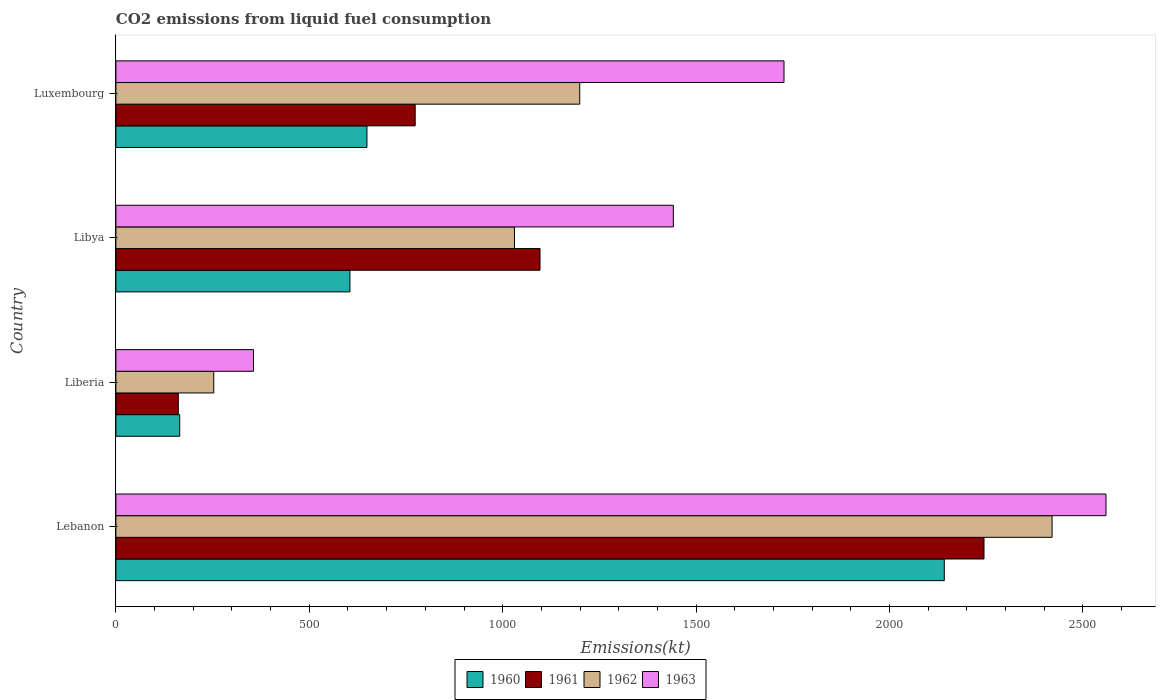How many bars are there on the 3rd tick from the top?
Offer a terse response. 4. How many bars are there on the 2nd tick from the bottom?
Make the answer very short. 4. What is the label of the 4th group of bars from the top?
Offer a terse response. Lebanon. What is the amount of CO2 emitted in 1963 in Libya?
Offer a very short reply. 1441.13. Across all countries, what is the maximum amount of CO2 emitted in 1961?
Give a very brief answer. 2244.2. Across all countries, what is the minimum amount of CO2 emitted in 1960?
Your answer should be very brief. 165.01. In which country was the amount of CO2 emitted in 1960 maximum?
Offer a very short reply. Lebanon. In which country was the amount of CO2 emitted in 1960 minimum?
Keep it short and to the point. Liberia. What is the total amount of CO2 emitted in 1963 in the graph?
Ensure brevity in your answer.  6083.55. What is the difference between the amount of CO2 emitted in 1962 in Lebanon and that in Liberia?
Make the answer very short. 2167.2. What is the difference between the amount of CO2 emitted in 1960 in Liberia and the amount of CO2 emitted in 1961 in Luxembourg?
Give a very brief answer. -608.72. What is the average amount of CO2 emitted in 1961 per country?
Provide a short and direct response. 1068.93. What is the difference between the amount of CO2 emitted in 1963 and amount of CO2 emitted in 1962 in Liberia?
Your answer should be compact. 102.68. What is the ratio of the amount of CO2 emitted in 1961 in Libya to that in Luxembourg?
Ensure brevity in your answer.  1.42. Is the amount of CO2 emitted in 1960 in Libya less than that in Luxembourg?
Offer a terse response. Yes. What is the difference between the highest and the second highest amount of CO2 emitted in 1960?
Keep it short and to the point. 1492.47. What is the difference between the highest and the lowest amount of CO2 emitted in 1960?
Offer a very short reply. 1976.51. In how many countries, is the amount of CO2 emitted in 1962 greater than the average amount of CO2 emitted in 1962 taken over all countries?
Keep it short and to the point. 1. Is it the case that in every country, the sum of the amount of CO2 emitted in 1961 and amount of CO2 emitted in 1963 is greater than the sum of amount of CO2 emitted in 1960 and amount of CO2 emitted in 1962?
Keep it short and to the point. No. How many bars are there?
Give a very brief answer. 16. Are all the bars in the graph horizontal?
Your answer should be very brief. Yes. Are the values on the major ticks of X-axis written in scientific E-notation?
Provide a succinct answer. No. Does the graph contain any zero values?
Keep it short and to the point. No. Does the graph contain grids?
Offer a very short reply. No. Where does the legend appear in the graph?
Keep it short and to the point. Bottom center. How many legend labels are there?
Make the answer very short. 4. What is the title of the graph?
Make the answer very short. CO2 emissions from liquid fuel consumption. What is the label or title of the X-axis?
Ensure brevity in your answer.  Emissions(kt). What is the label or title of the Y-axis?
Keep it short and to the point. Country. What is the Emissions(kt) of 1960 in Lebanon?
Offer a terse response. 2141.53. What is the Emissions(kt) of 1961 in Lebanon?
Give a very brief answer. 2244.2. What is the Emissions(kt) of 1962 in Lebanon?
Your response must be concise. 2420.22. What is the Emissions(kt) of 1963 in Lebanon?
Offer a terse response. 2559.57. What is the Emissions(kt) in 1960 in Liberia?
Provide a short and direct response. 165.01. What is the Emissions(kt) of 1961 in Liberia?
Offer a very short reply. 161.35. What is the Emissions(kt) in 1962 in Liberia?
Your response must be concise. 253.02. What is the Emissions(kt) of 1963 in Liberia?
Your answer should be compact. 355.7. What is the Emissions(kt) in 1960 in Libya?
Make the answer very short. 605.05. What is the Emissions(kt) of 1961 in Libya?
Provide a succinct answer. 1096.43. What is the Emissions(kt) of 1962 in Libya?
Ensure brevity in your answer.  1030.43. What is the Emissions(kt) of 1963 in Libya?
Your answer should be very brief. 1441.13. What is the Emissions(kt) in 1960 in Luxembourg?
Keep it short and to the point. 649.06. What is the Emissions(kt) in 1961 in Luxembourg?
Ensure brevity in your answer.  773.74. What is the Emissions(kt) of 1962 in Luxembourg?
Offer a terse response. 1199.11. What is the Emissions(kt) of 1963 in Luxembourg?
Give a very brief answer. 1727.16. Across all countries, what is the maximum Emissions(kt) in 1960?
Keep it short and to the point. 2141.53. Across all countries, what is the maximum Emissions(kt) in 1961?
Provide a succinct answer. 2244.2. Across all countries, what is the maximum Emissions(kt) of 1962?
Offer a very short reply. 2420.22. Across all countries, what is the maximum Emissions(kt) of 1963?
Your answer should be compact. 2559.57. Across all countries, what is the minimum Emissions(kt) in 1960?
Give a very brief answer. 165.01. Across all countries, what is the minimum Emissions(kt) in 1961?
Offer a terse response. 161.35. Across all countries, what is the minimum Emissions(kt) of 1962?
Your response must be concise. 253.02. Across all countries, what is the minimum Emissions(kt) in 1963?
Give a very brief answer. 355.7. What is the total Emissions(kt) in 1960 in the graph?
Your answer should be compact. 3560.66. What is the total Emissions(kt) in 1961 in the graph?
Offer a terse response. 4275.72. What is the total Emissions(kt) of 1962 in the graph?
Provide a short and direct response. 4902.78. What is the total Emissions(kt) in 1963 in the graph?
Provide a succinct answer. 6083.55. What is the difference between the Emissions(kt) in 1960 in Lebanon and that in Liberia?
Your answer should be very brief. 1976.51. What is the difference between the Emissions(kt) of 1961 in Lebanon and that in Liberia?
Ensure brevity in your answer.  2082.86. What is the difference between the Emissions(kt) of 1962 in Lebanon and that in Liberia?
Offer a very short reply. 2167.2. What is the difference between the Emissions(kt) of 1963 in Lebanon and that in Liberia?
Your response must be concise. 2203.87. What is the difference between the Emissions(kt) in 1960 in Lebanon and that in Libya?
Make the answer very short. 1536.47. What is the difference between the Emissions(kt) of 1961 in Lebanon and that in Libya?
Keep it short and to the point. 1147.77. What is the difference between the Emissions(kt) in 1962 in Lebanon and that in Libya?
Provide a short and direct response. 1389.79. What is the difference between the Emissions(kt) in 1963 in Lebanon and that in Libya?
Your answer should be compact. 1118.43. What is the difference between the Emissions(kt) of 1960 in Lebanon and that in Luxembourg?
Provide a succinct answer. 1492.47. What is the difference between the Emissions(kt) of 1961 in Lebanon and that in Luxembourg?
Give a very brief answer. 1470.47. What is the difference between the Emissions(kt) in 1962 in Lebanon and that in Luxembourg?
Offer a terse response. 1221.11. What is the difference between the Emissions(kt) of 1963 in Lebanon and that in Luxembourg?
Offer a very short reply. 832.41. What is the difference between the Emissions(kt) in 1960 in Liberia and that in Libya?
Keep it short and to the point. -440.04. What is the difference between the Emissions(kt) in 1961 in Liberia and that in Libya?
Offer a very short reply. -935.09. What is the difference between the Emissions(kt) of 1962 in Liberia and that in Libya?
Your answer should be compact. -777.4. What is the difference between the Emissions(kt) in 1963 in Liberia and that in Libya?
Offer a very short reply. -1085.43. What is the difference between the Emissions(kt) in 1960 in Liberia and that in Luxembourg?
Provide a short and direct response. -484.04. What is the difference between the Emissions(kt) of 1961 in Liberia and that in Luxembourg?
Offer a terse response. -612.39. What is the difference between the Emissions(kt) in 1962 in Liberia and that in Luxembourg?
Keep it short and to the point. -946.09. What is the difference between the Emissions(kt) of 1963 in Liberia and that in Luxembourg?
Provide a succinct answer. -1371.46. What is the difference between the Emissions(kt) of 1960 in Libya and that in Luxembourg?
Offer a terse response. -44. What is the difference between the Emissions(kt) in 1961 in Libya and that in Luxembourg?
Your answer should be very brief. 322.7. What is the difference between the Emissions(kt) of 1962 in Libya and that in Luxembourg?
Keep it short and to the point. -168.68. What is the difference between the Emissions(kt) in 1963 in Libya and that in Luxembourg?
Ensure brevity in your answer.  -286.03. What is the difference between the Emissions(kt) in 1960 in Lebanon and the Emissions(kt) in 1961 in Liberia?
Offer a terse response. 1980.18. What is the difference between the Emissions(kt) of 1960 in Lebanon and the Emissions(kt) of 1962 in Liberia?
Keep it short and to the point. 1888.51. What is the difference between the Emissions(kt) in 1960 in Lebanon and the Emissions(kt) in 1963 in Liberia?
Provide a succinct answer. 1785.83. What is the difference between the Emissions(kt) in 1961 in Lebanon and the Emissions(kt) in 1962 in Liberia?
Your answer should be compact. 1991.18. What is the difference between the Emissions(kt) in 1961 in Lebanon and the Emissions(kt) in 1963 in Liberia?
Keep it short and to the point. 1888.51. What is the difference between the Emissions(kt) in 1962 in Lebanon and the Emissions(kt) in 1963 in Liberia?
Provide a succinct answer. 2064.52. What is the difference between the Emissions(kt) of 1960 in Lebanon and the Emissions(kt) of 1961 in Libya?
Give a very brief answer. 1045.1. What is the difference between the Emissions(kt) in 1960 in Lebanon and the Emissions(kt) in 1962 in Libya?
Your response must be concise. 1111.1. What is the difference between the Emissions(kt) in 1960 in Lebanon and the Emissions(kt) in 1963 in Libya?
Give a very brief answer. 700.4. What is the difference between the Emissions(kt) of 1961 in Lebanon and the Emissions(kt) of 1962 in Libya?
Offer a very short reply. 1213.78. What is the difference between the Emissions(kt) in 1961 in Lebanon and the Emissions(kt) in 1963 in Libya?
Give a very brief answer. 803.07. What is the difference between the Emissions(kt) of 1962 in Lebanon and the Emissions(kt) of 1963 in Libya?
Provide a short and direct response. 979.09. What is the difference between the Emissions(kt) of 1960 in Lebanon and the Emissions(kt) of 1961 in Luxembourg?
Your answer should be very brief. 1367.79. What is the difference between the Emissions(kt) of 1960 in Lebanon and the Emissions(kt) of 1962 in Luxembourg?
Make the answer very short. 942.42. What is the difference between the Emissions(kt) in 1960 in Lebanon and the Emissions(kt) in 1963 in Luxembourg?
Your answer should be very brief. 414.37. What is the difference between the Emissions(kt) in 1961 in Lebanon and the Emissions(kt) in 1962 in Luxembourg?
Give a very brief answer. 1045.1. What is the difference between the Emissions(kt) of 1961 in Lebanon and the Emissions(kt) of 1963 in Luxembourg?
Provide a short and direct response. 517.05. What is the difference between the Emissions(kt) of 1962 in Lebanon and the Emissions(kt) of 1963 in Luxembourg?
Offer a terse response. 693.06. What is the difference between the Emissions(kt) in 1960 in Liberia and the Emissions(kt) in 1961 in Libya?
Keep it short and to the point. -931.42. What is the difference between the Emissions(kt) of 1960 in Liberia and the Emissions(kt) of 1962 in Libya?
Your answer should be compact. -865.41. What is the difference between the Emissions(kt) of 1960 in Liberia and the Emissions(kt) of 1963 in Libya?
Ensure brevity in your answer.  -1276.12. What is the difference between the Emissions(kt) of 1961 in Liberia and the Emissions(kt) of 1962 in Libya?
Provide a succinct answer. -869.08. What is the difference between the Emissions(kt) in 1961 in Liberia and the Emissions(kt) in 1963 in Libya?
Offer a terse response. -1279.78. What is the difference between the Emissions(kt) of 1962 in Liberia and the Emissions(kt) of 1963 in Libya?
Your answer should be very brief. -1188.11. What is the difference between the Emissions(kt) of 1960 in Liberia and the Emissions(kt) of 1961 in Luxembourg?
Ensure brevity in your answer.  -608.72. What is the difference between the Emissions(kt) in 1960 in Liberia and the Emissions(kt) in 1962 in Luxembourg?
Keep it short and to the point. -1034.09. What is the difference between the Emissions(kt) of 1960 in Liberia and the Emissions(kt) of 1963 in Luxembourg?
Give a very brief answer. -1562.14. What is the difference between the Emissions(kt) in 1961 in Liberia and the Emissions(kt) in 1962 in Luxembourg?
Your response must be concise. -1037.76. What is the difference between the Emissions(kt) of 1961 in Liberia and the Emissions(kt) of 1963 in Luxembourg?
Provide a short and direct response. -1565.81. What is the difference between the Emissions(kt) in 1962 in Liberia and the Emissions(kt) in 1963 in Luxembourg?
Make the answer very short. -1474.13. What is the difference between the Emissions(kt) of 1960 in Libya and the Emissions(kt) of 1961 in Luxembourg?
Ensure brevity in your answer.  -168.68. What is the difference between the Emissions(kt) of 1960 in Libya and the Emissions(kt) of 1962 in Luxembourg?
Keep it short and to the point. -594.05. What is the difference between the Emissions(kt) in 1960 in Libya and the Emissions(kt) in 1963 in Luxembourg?
Give a very brief answer. -1122.1. What is the difference between the Emissions(kt) of 1961 in Libya and the Emissions(kt) of 1962 in Luxembourg?
Offer a terse response. -102.68. What is the difference between the Emissions(kt) in 1961 in Libya and the Emissions(kt) in 1963 in Luxembourg?
Provide a succinct answer. -630.72. What is the difference between the Emissions(kt) of 1962 in Libya and the Emissions(kt) of 1963 in Luxembourg?
Offer a terse response. -696.73. What is the average Emissions(kt) in 1960 per country?
Offer a terse response. 890.16. What is the average Emissions(kt) in 1961 per country?
Ensure brevity in your answer.  1068.93. What is the average Emissions(kt) of 1962 per country?
Make the answer very short. 1225.69. What is the average Emissions(kt) in 1963 per country?
Provide a succinct answer. 1520.89. What is the difference between the Emissions(kt) of 1960 and Emissions(kt) of 1961 in Lebanon?
Offer a very short reply. -102.68. What is the difference between the Emissions(kt) in 1960 and Emissions(kt) in 1962 in Lebanon?
Make the answer very short. -278.69. What is the difference between the Emissions(kt) of 1960 and Emissions(kt) of 1963 in Lebanon?
Your answer should be compact. -418.04. What is the difference between the Emissions(kt) in 1961 and Emissions(kt) in 1962 in Lebanon?
Keep it short and to the point. -176.02. What is the difference between the Emissions(kt) of 1961 and Emissions(kt) of 1963 in Lebanon?
Make the answer very short. -315.36. What is the difference between the Emissions(kt) of 1962 and Emissions(kt) of 1963 in Lebanon?
Your response must be concise. -139.35. What is the difference between the Emissions(kt) of 1960 and Emissions(kt) of 1961 in Liberia?
Your answer should be compact. 3.67. What is the difference between the Emissions(kt) in 1960 and Emissions(kt) in 1962 in Liberia?
Give a very brief answer. -88.01. What is the difference between the Emissions(kt) of 1960 and Emissions(kt) of 1963 in Liberia?
Your response must be concise. -190.68. What is the difference between the Emissions(kt) of 1961 and Emissions(kt) of 1962 in Liberia?
Your response must be concise. -91.67. What is the difference between the Emissions(kt) of 1961 and Emissions(kt) of 1963 in Liberia?
Make the answer very short. -194.35. What is the difference between the Emissions(kt) of 1962 and Emissions(kt) of 1963 in Liberia?
Keep it short and to the point. -102.68. What is the difference between the Emissions(kt) of 1960 and Emissions(kt) of 1961 in Libya?
Offer a very short reply. -491.38. What is the difference between the Emissions(kt) of 1960 and Emissions(kt) of 1962 in Libya?
Your response must be concise. -425.37. What is the difference between the Emissions(kt) in 1960 and Emissions(kt) in 1963 in Libya?
Your answer should be very brief. -836.08. What is the difference between the Emissions(kt) of 1961 and Emissions(kt) of 1962 in Libya?
Offer a terse response. 66.01. What is the difference between the Emissions(kt) of 1961 and Emissions(kt) of 1963 in Libya?
Make the answer very short. -344.7. What is the difference between the Emissions(kt) in 1962 and Emissions(kt) in 1963 in Libya?
Offer a very short reply. -410.7. What is the difference between the Emissions(kt) of 1960 and Emissions(kt) of 1961 in Luxembourg?
Your answer should be very brief. -124.68. What is the difference between the Emissions(kt) in 1960 and Emissions(kt) in 1962 in Luxembourg?
Keep it short and to the point. -550.05. What is the difference between the Emissions(kt) in 1960 and Emissions(kt) in 1963 in Luxembourg?
Your response must be concise. -1078.1. What is the difference between the Emissions(kt) in 1961 and Emissions(kt) in 1962 in Luxembourg?
Your response must be concise. -425.37. What is the difference between the Emissions(kt) in 1961 and Emissions(kt) in 1963 in Luxembourg?
Ensure brevity in your answer.  -953.42. What is the difference between the Emissions(kt) in 1962 and Emissions(kt) in 1963 in Luxembourg?
Your answer should be very brief. -528.05. What is the ratio of the Emissions(kt) of 1960 in Lebanon to that in Liberia?
Provide a short and direct response. 12.98. What is the ratio of the Emissions(kt) in 1961 in Lebanon to that in Liberia?
Offer a terse response. 13.91. What is the ratio of the Emissions(kt) of 1962 in Lebanon to that in Liberia?
Your answer should be very brief. 9.57. What is the ratio of the Emissions(kt) of 1963 in Lebanon to that in Liberia?
Your answer should be compact. 7.2. What is the ratio of the Emissions(kt) in 1960 in Lebanon to that in Libya?
Ensure brevity in your answer.  3.54. What is the ratio of the Emissions(kt) in 1961 in Lebanon to that in Libya?
Give a very brief answer. 2.05. What is the ratio of the Emissions(kt) of 1962 in Lebanon to that in Libya?
Offer a terse response. 2.35. What is the ratio of the Emissions(kt) in 1963 in Lebanon to that in Libya?
Your answer should be very brief. 1.78. What is the ratio of the Emissions(kt) in 1960 in Lebanon to that in Luxembourg?
Your response must be concise. 3.3. What is the ratio of the Emissions(kt) in 1961 in Lebanon to that in Luxembourg?
Provide a short and direct response. 2.9. What is the ratio of the Emissions(kt) in 1962 in Lebanon to that in Luxembourg?
Your response must be concise. 2.02. What is the ratio of the Emissions(kt) of 1963 in Lebanon to that in Luxembourg?
Ensure brevity in your answer.  1.48. What is the ratio of the Emissions(kt) of 1960 in Liberia to that in Libya?
Offer a very short reply. 0.27. What is the ratio of the Emissions(kt) in 1961 in Liberia to that in Libya?
Your answer should be compact. 0.15. What is the ratio of the Emissions(kt) in 1962 in Liberia to that in Libya?
Offer a very short reply. 0.25. What is the ratio of the Emissions(kt) in 1963 in Liberia to that in Libya?
Provide a short and direct response. 0.25. What is the ratio of the Emissions(kt) of 1960 in Liberia to that in Luxembourg?
Ensure brevity in your answer.  0.25. What is the ratio of the Emissions(kt) of 1961 in Liberia to that in Luxembourg?
Offer a terse response. 0.21. What is the ratio of the Emissions(kt) of 1962 in Liberia to that in Luxembourg?
Provide a succinct answer. 0.21. What is the ratio of the Emissions(kt) in 1963 in Liberia to that in Luxembourg?
Provide a succinct answer. 0.21. What is the ratio of the Emissions(kt) of 1960 in Libya to that in Luxembourg?
Your answer should be very brief. 0.93. What is the ratio of the Emissions(kt) of 1961 in Libya to that in Luxembourg?
Offer a terse response. 1.42. What is the ratio of the Emissions(kt) in 1962 in Libya to that in Luxembourg?
Your answer should be very brief. 0.86. What is the ratio of the Emissions(kt) of 1963 in Libya to that in Luxembourg?
Your response must be concise. 0.83. What is the difference between the highest and the second highest Emissions(kt) in 1960?
Provide a succinct answer. 1492.47. What is the difference between the highest and the second highest Emissions(kt) in 1961?
Provide a short and direct response. 1147.77. What is the difference between the highest and the second highest Emissions(kt) in 1962?
Offer a terse response. 1221.11. What is the difference between the highest and the second highest Emissions(kt) in 1963?
Offer a terse response. 832.41. What is the difference between the highest and the lowest Emissions(kt) in 1960?
Ensure brevity in your answer.  1976.51. What is the difference between the highest and the lowest Emissions(kt) of 1961?
Your answer should be compact. 2082.86. What is the difference between the highest and the lowest Emissions(kt) in 1962?
Your response must be concise. 2167.2. What is the difference between the highest and the lowest Emissions(kt) of 1963?
Give a very brief answer. 2203.87. 